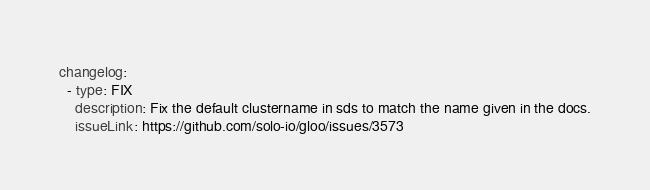<code> <loc_0><loc_0><loc_500><loc_500><_YAML_>changelog:
  - type: FIX
    description: Fix the default clustername in sds to match the name given in the docs.
    issueLink: https://github.com/solo-io/gloo/issues/3573
</code> 